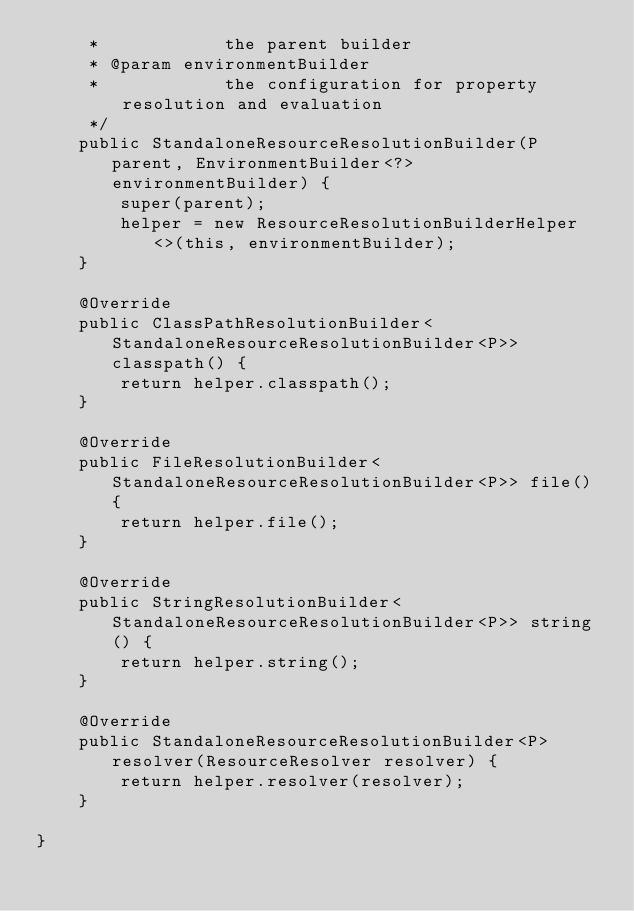Convert code to text. <code><loc_0><loc_0><loc_500><loc_500><_Java_>	 *            the parent builder
	 * @param environmentBuilder
	 *            the configuration for property resolution and evaluation
	 */
	public StandaloneResourceResolutionBuilder(P parent, EnvironmentBuilder<?> environmentBuilder) {
		super(parent);
		helper = new ResourceResolutionBuilderHelper<>(this, environmentBuilder);
	}

	@Override
	public ClassPathResolutionBuilder<StandaloneResourceResolutionBuilder<P>> classpath() {
		return helper.classpath();
	}

	@Override
	public FileResolutionBuilder<StandaloneResourceResolutionBuilder<P>> file() {
		return helper.file();
	}

	@Override
	public StringResolutionBuilder<StandaloneResourceResolutionBuilder<P>> string() {
		return helper.string();
	}

	@Override
	public StandaloneResourceResolutionBuilder<P> resolver(ResourceResolver resolver) {
		return helper.resolver(resolver);
	}

}
</code> 